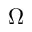Convert formula to latex. <formula><loc_0><loc_0><loc_500><loc_500>\Omega</formula> 